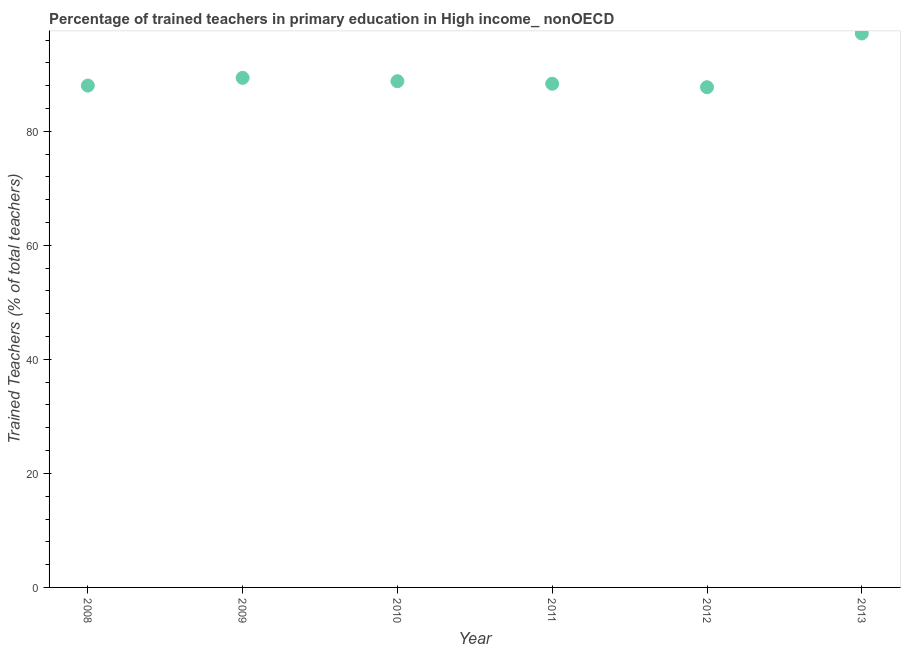What is the percentage of trained teachers in 2013?
Give a very brief answer. 97.15. Across all years, what is the maximum percentage of trained teachers?
Ensure brevity in your answer.  97.15. Across all years, what is the minimum percentage of trained teachers?
Keep it short and to the point. 87.73. In which year was the percentage of trained teachers minimum?
Give a very brief answer. 2012. What is the sum of the percentage of trained teachers?
Offer a terse response. 539.39. What is the difference between the percentage of trained teachers in 2008 and 2012?
Your response must be concise. 0.29. What is the average percentage of trained teachers per year?
Ensure brevity in your answer.  89.9. What is the median percentage of trained teachers?
Ensure brevity in your answer.  88.56. Do a majority of the years between 2010 and 2011 (inclusive) have percentage of trained teachers greater than 24 %?
Ensure brevity in your answer.  Yes. What is the ratio of the percentage of trained teachers in 2008 to that in 2009?
Your answer should be compact. 0.98. Is the percentage of trained teachers in 2010 less than that in 2011?
Provide a succinct answer. No. What is the difference between the highest and the second highest percentage of trained teachers?
Your response must be concise. 7.78. What is the difference between the highest and the lowest percentage of trained teachers?
Offer a terse response. 9.42. In how many years, is the percentage of trained teachers greater than the average percentage of trained teachers taken over all years?
Provide a succinct answer. 1. Does the percentage of trained teachers monotonically increase over the years?
Keep it short and to the point. No. How many dotlines are there?
Provide a short and direct response. 1. What is the difference between two consecutive major ticks on the Y-axis?
Make the answer very short. 20. Does the graph contain any zero values?
Ensure brevity in your answer.  No. What is the title of the graph?
Give a very brief answer. Percentage of trained teachers in primary education in High income_ nonOECD. What is the label or title of the Y-axis?
Your answer should be very brief. Trained Teachers (% of total teachers). What is the Trained Teachers (% of total teachers) in 2008?
Your answer should be very brief. 88.02. What is the Trained Teachers (% of total teachers) in 2009?
Your response must be concise. 89.37. What is the Trained Teachers (% of total teachers) in 2010?
Keep it short and to the point. 88.79. What is the Trained Teachers (% of total teachers) in 2011?
Give a very brief answer. 88.34. What is the Trained Teachers (% of total teachers) in 2012?
Offer a terse response. 87.73. What is the Trained Teachers (% of total teachers) in 2013?
Provide a short and direct response. 97.15. What is the difference between the Trained Teachers (% of total teachers) in 2008 and 2009?
Keep it short and to the point. -1.35. What is the difference between the Trained Teachers (% of total teachers) in 2008 and 2010?
Your answer should be compact. -0.77. What is the difference between the Trained Teachers (% of total teachers) in 2008 and 2011?
Make the answer very short. -0.32. What is the difference between the Trained Teachers (% of total teachers) in 2008 and 2012?
Make the answer very short. 0.29. What is the difference between the Trained Teachers (% of total teachers) in 2008 and 2013?
Your response must be concise. -9.13. What is the difference between the Trained Teachers (% of total teachers) in 2009 and 2010?
Keep it short and to the point. 0.58. What is the difference between the Trained Teachers (% of total teachers) in 2009 and 2011?
Give a very brief answer. 1.03. What is the difference between the Trained Teachers (% of total teachers) in 2009 and 2012?
Your answer should be very brief. 1.64. What is the difference between the Trained Teachers (% of total teachers) in 2009 and 2013?
Your answer should be compact. -7.78. What is the difference between the Trained Teachers (% of total teachers) in 2010 and 2011?
Keep it short and to the point. 0.45. What is the difference between the Trained Teachers (% of total teachers) in 2010 and 2012?
Provide a short and direct response. 1.06. What is the difference between the Trained Teachers (% of total teachers) in 2010 and 2013?
Make the answer very short. -8.36. What is the difference between the Trained Teachers (% of total teachers) in 2011 and 2012?
Ensure brevity in your answer.  0.61. What is the difference between the Trained Teachers (% of total teachers) in 2011 and 2013?
Your response must be concise. -8.81. What is the difference between the Trained Teachers (% of total teachers) in 2012 and 2013?
Offer a terse response. -9.42. What is the ratio of the Trained Teachers (% of total teachers) in 2008 to that in 2010?
Ensure brevity in your answer.  0.99. What is the ratio of the Trained Teachers (% of total teachers) in 2008 to that in 2012?
Provide a succinct answer. 1. What is the ratio of the Trained Teachers (% of total teachers) in 2008 to that in 2013?
Your answer should be compact. 0.91. What is the ratio of the Trained Teachers (% of total teachers) in 2009 to that in 2010?
Provide a succinct answer. 1.01. What is the ratio of the Trained Teachers (% of total teachers) in 2009 to that in 2013?
Ensure brevity in your answer.  0.92. What is the ratio of the Trained Teachers (% of total teachers) in 2010 to that in 2013?
Your response must be concise. 0.91. What is the ratio of the Trained Teachers (% of total teachers) in 2011 to that in 2012?
Make the answer very short. 1.01. What is the ratio of the Trained Teachers (% of total teachers) in 2011 to that in 2013?
Provide a short and direct response. 0.91. What is the ratio of the Trained Teachers (% of total teachers) in 2012 to that in 2013?
Give a very brief answer. 0.9. 